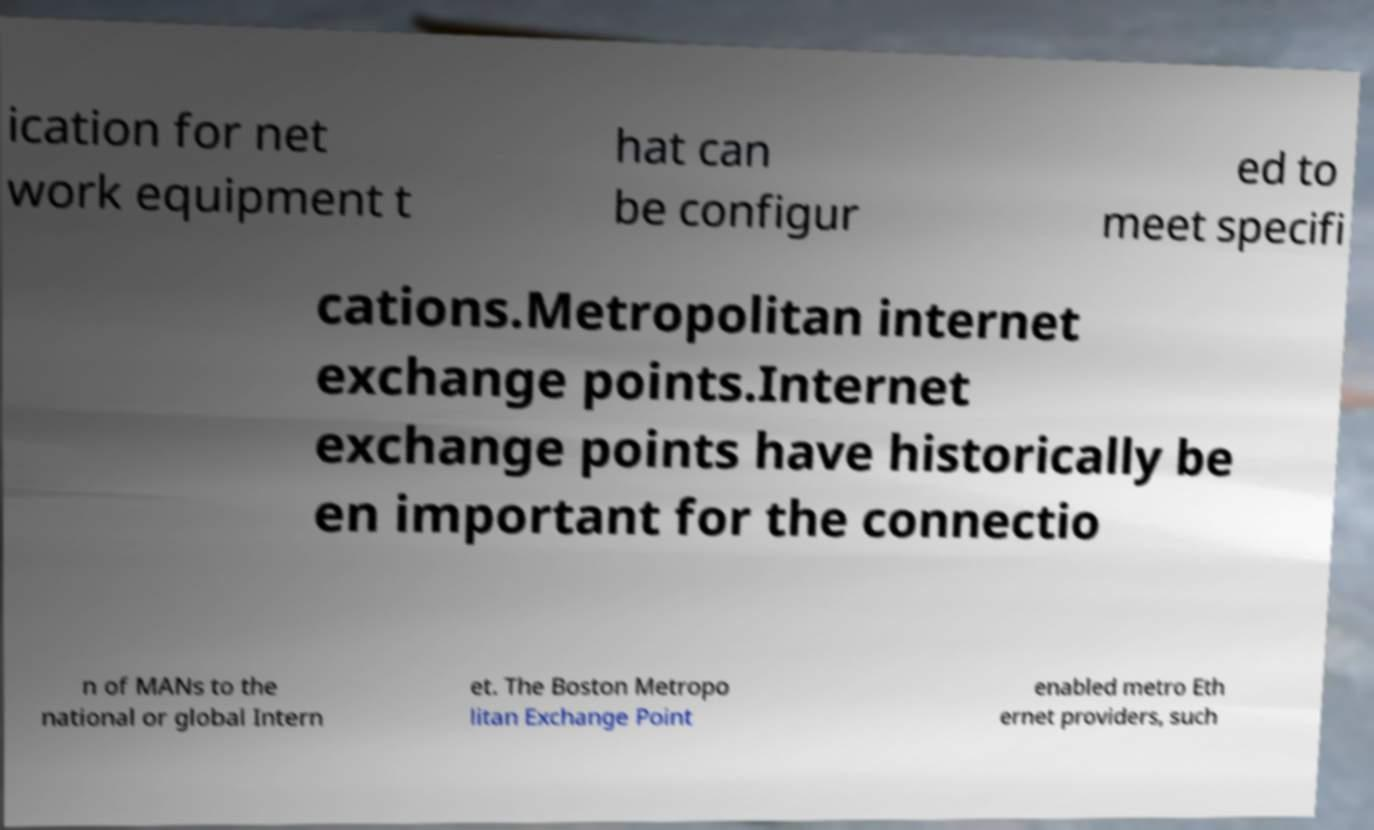Please identify and transcribe the text found in this image. ication for net work equipment t hat can be configur ed to meet specifi cations.Metropolitan internet exchange points.Internet exchange points have historically be en important for the connectio n of MANs to the national or global Intern et. The Boston Metropo litan Exchange Point enabled metro Eth ernet providers, such 